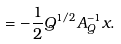<formula> <loc_0><loc_0><loc_500><loc_500>= - \frac { 1 } { 2 } Q ^ { 1 / 2 } A _ { Q } ^ { - 1 } x .</formula> 